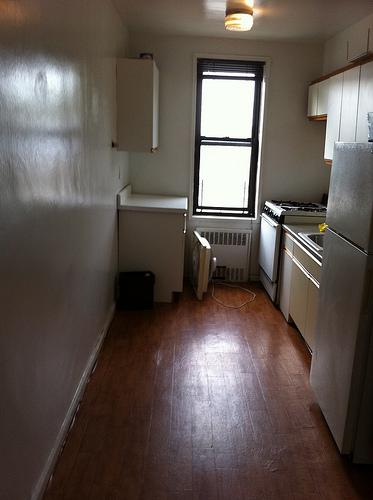Question: what color is the floor?
Choices:
A. Black.
B. White.
C. Blue.
D. Brown.
Answer with the letter. Answer: D Question: how many window panes are seen?
Choices:
A. Three.
B. Four.
C. Five.
D. Two.
Answer with the letter. Answer: D Question: what is supplying the light for the photo?
Choices:
A. Flash.
B. Sun.
C. Moon.
D. Lightbulb.
Answer with the letter. Answer: B Question: where is the photo taken?
Choices:
A. Kitchen.
B. Restaurant.
C. Beach.
D. Zoo.
Answer with the letter. Answer: A Question: what is the appliance nearest the window on the right side?
Choices:
A. Stove.
B. Toaster.
C. Microwave.
D. Blender.
Answer with the letter. Answer: A 